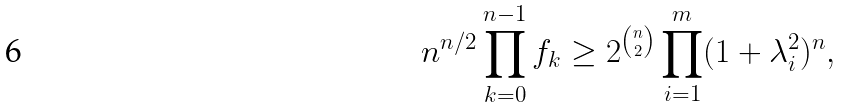Convert formula to latex. <formula><loc_0><loc_0><loc_500><loc_500>n ^ { n / 2 } \prod _ { k = 0 } ^ { n - 1 } f _ { k } \geq 2 ^ { \binom { n } { 2 } } \prod _ { i = 1 } ^ { m } ( 1 + \lambda _ { i } ^ { 2 } ) ^ { n } ,</formula> 